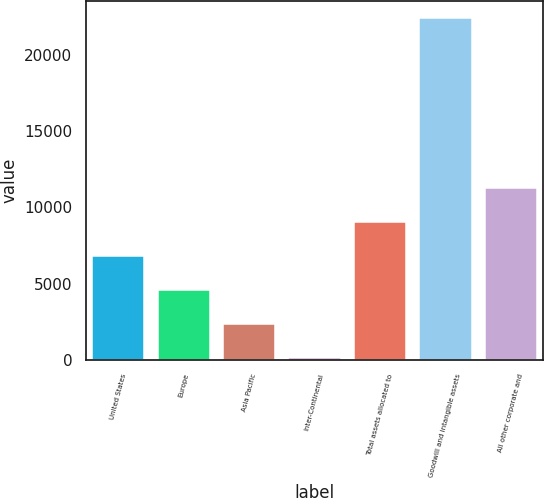<chart> <loc_0><loc_0><loc_500><loc_500><bar_chart><fcel>United States<fcel>Europe<fcel>Asia Pacific<fcel>Inter-Continental<fcel>Total assets allocated to<fcel>Goodwill and intangible assets<fcel>All other corporate and<nl><fcel>6812.8<fcel>4589.2<fcel>2365.6<fcel>142<fcel>9036.4<fcel>22378<fcel>11260<nl></chart> 